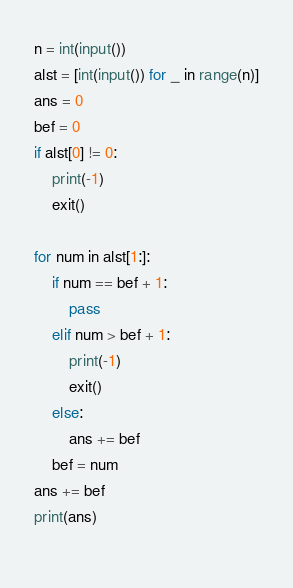<code> <loc_0><loc_0><loc_500><loc_500><_Python_>n = int(input())
alst = [int(input()) for _ in range(n)]
ans = 0
bef = 0
if alst[0] != 0:
    print(-1)
    exit()
    
for num in alst[1:]:
    if num == bef + 1:
        pass
    elif num > bef + 1:
        print(-1)
        exit()
    else:
        ans += bef
    bef = num
ans += bef
print(ans)
    </code> 